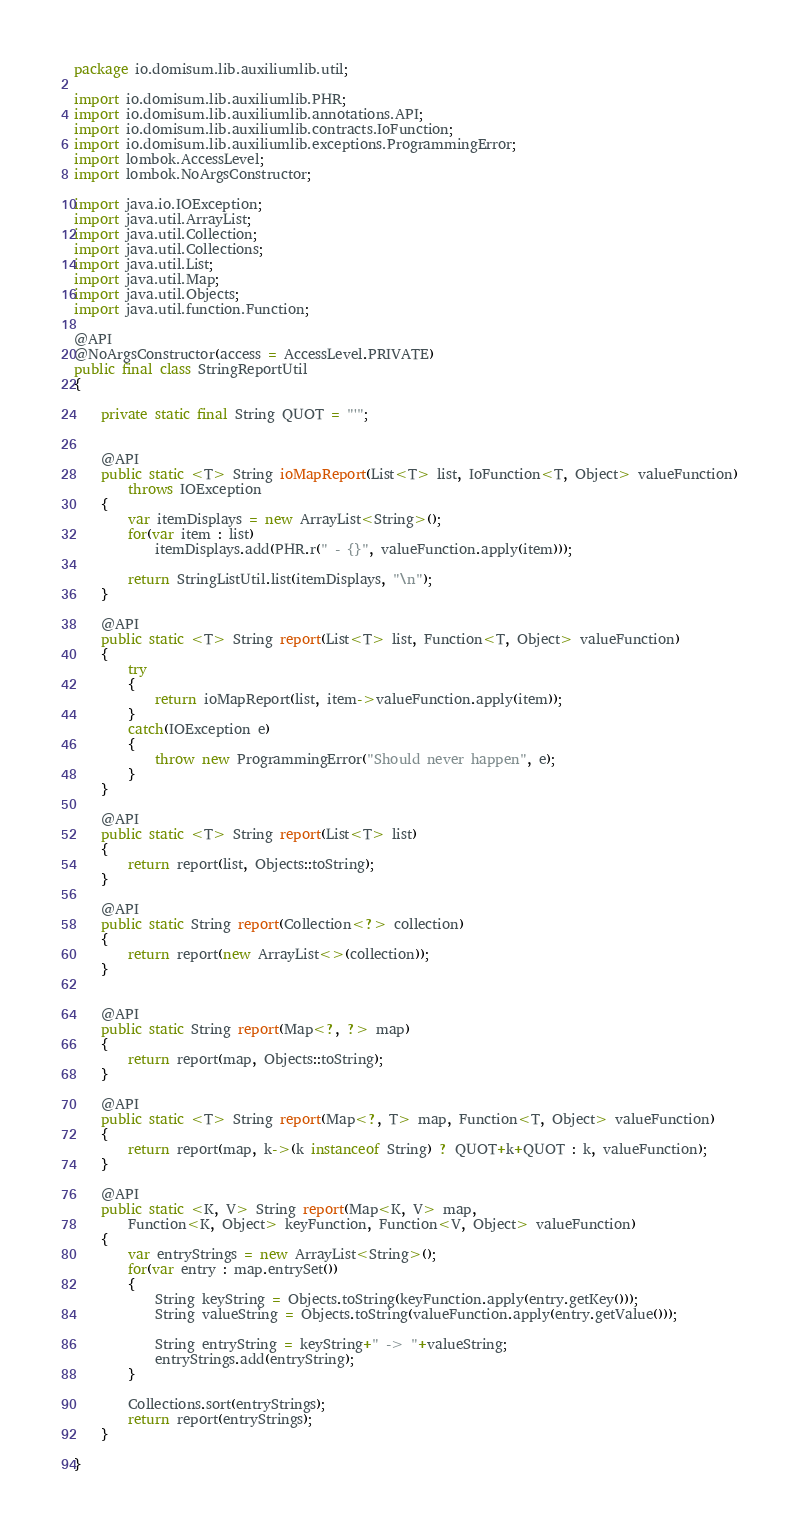<code> <loc_0><loc_0><loc_500><loc_500><_Java_>package io.domisum.lib.auxiliumlib.util;

import io.domisum.lib.auxiliumlib.PHR;
import io.domisum.lib.auxiliumlib.annotations.API;
import io.domisum.lib.auxiliumlib.contracts.IoFunction;
import io.domisum.lib.auxiliumlib.exceptions.ProgrammingError;
import lombok.AccessLevel;
import lombok.NoArgsConstructor;

import java.io.IOException;
import java.util.ArrayList;
import java.util.Collection;
import java.util.Collections;
import java.util.List;
import java.util.Map;
import java.util.Objects;
import java.util.function.Function;

@API
@NoArgsConstructor(access = AccessLevel.PRIVATE)
public final class StringReportUtil
{
	
	private static final String QUOT = "'";
	
	
	@API
	public static <T> String ioMapReport(List<T> list, IoFunction<T, Object> valueFunction)
		throws IOException
	{
		var itemDisplays = new ArrayList<String>();
		for(var item : list)
			itemDisplays.add(PHR.r(" - {}", valueFunction.apply(item)));
		
		return StringListUtil.list(itemDisplays, "\n");
	}
	
	@API
	public static <T> String report(List<T> list, Function<T, Object> valueFunction)
	{
		try
		{
			return ioMapReport(list, item->valueFunction.apply(item));
		}
		catch(IOException e)
		{
			throw new ProgrammingError("Should never happen", e);
		}
	}
	
	@API
	public static <T> String report(List<T> list)
	{
		return report(list, Objects::toString);
	}
	
	@API
	public static String report(Collection<?> collection)
	{
		return report(new ArrayList<>(collection));
	}
	
	
	@API
	public static String report(Map<?, ?> map)
	{
		return report(map, Objects::toString);
	}
	
	@API
	public static <T> String report(Map<?, T> map, Function<T, Object> valueFunction)
	{
		return report(map, k->(k instanceof String) ? QUOT+k+QUOT : k, valueFunction);
	}
	
	@API
	public static <K, V> String report(Map<K, V> map,
		Function<K, Object> keyFunction, Function<V, Object> valueFunction)
	{
		var entryStrings = new ArrayList<String>();
		for(var entry : map.entrySet())
		{
			String keyString = Objects.toString(keyFunction.apply(entry.getKey()));
			String valueString = Objects.toString(valueFunction.apply(entry.getValue()));
			
			String entryString = keyString+" -> "+valueString;
			entryStrings.add(entryString);
		}
		
		Collections.sort(entryStrings);
		return report(entryStrings);
	}
	
}
</code> 